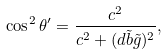Convert formula to latex. <formula><loc_0><loc_0><loc_500><loc_500>\cos ^ { 2 } \theta ^ { \prime } = \frac { c ^ { 2 } } { c ^ { 2 } + ( d { \tilde { b } } { \tilde { g } } ) ^ { 2 } } ,</formula> 